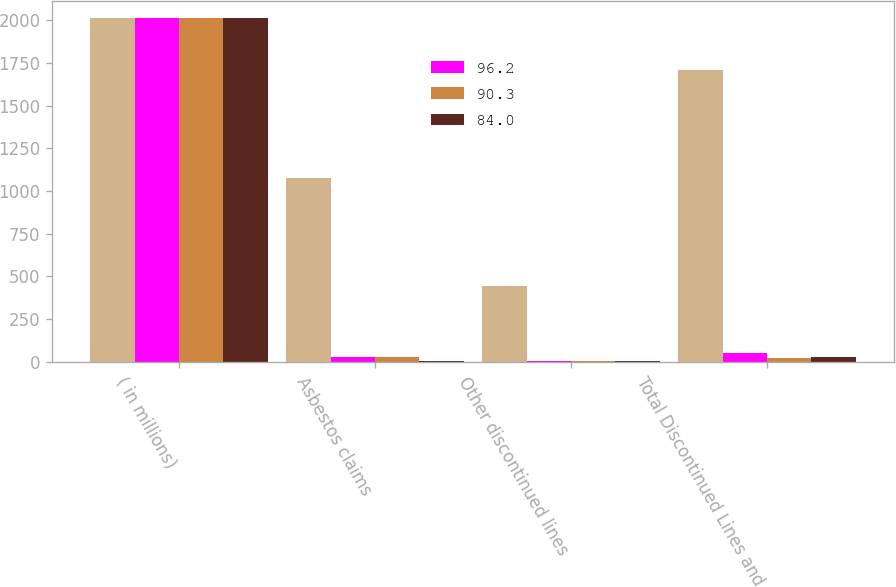<chart> <loc_0><loc_0><loc_500><loc_500><stacked_bar_chart><ecel><fcel>( in millions)<fcel>Asbestos claims<fcel>Other discontinued lines<fcel>Total Discontinued Lines and<nl><fcel>nan<fcel>2012<fcel>1078<fcel>444<fcel>1707<nl><fcel>96.2<fcel>2012<fcel>26<fcel>3<fcel>51<nl><fcel>90.3<fcel>2011<fcel>26<fcel>5<fcel>21<nl><fcel>84<fcel>2010<fcel>5<fcel>5<fcel>28<nl></chart> 